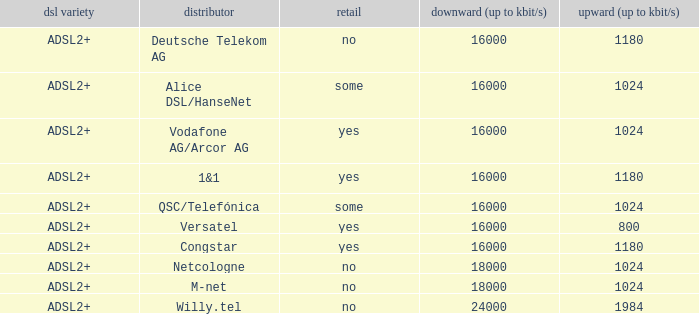What are all the dsl type offered by the M-Net telecom company? ADSL2+. 